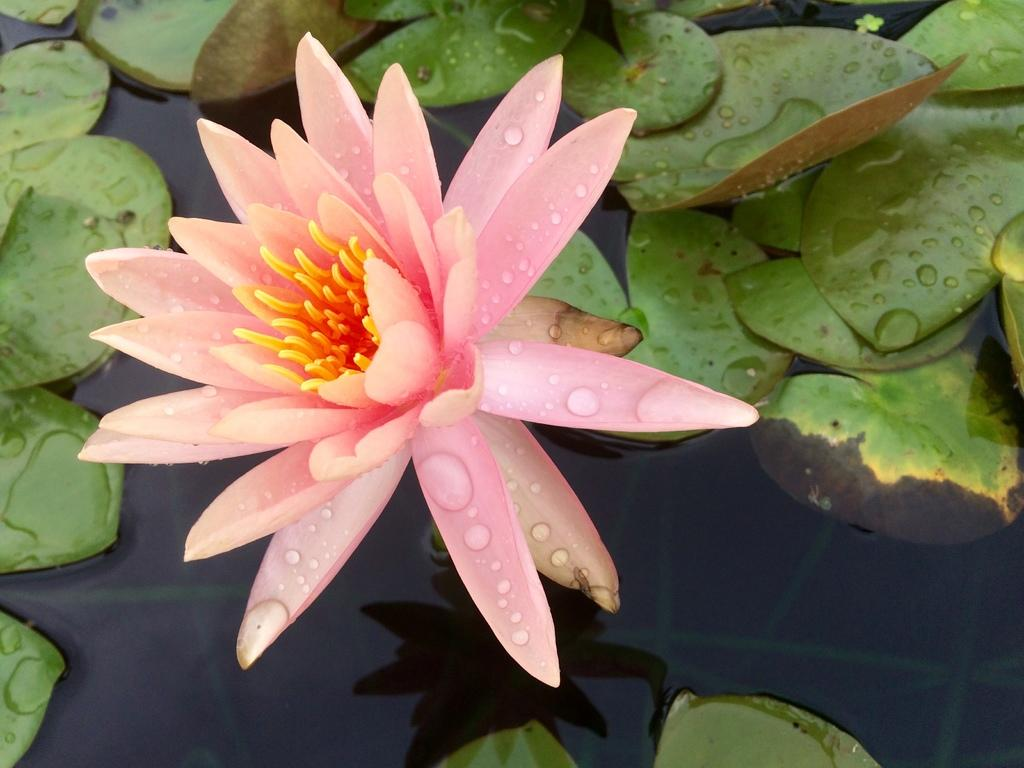What is the primary element visible in the image? There is water in the image. What type of plant material can be seen in the image? There are leaves in the image. What color is the flower in the image? There is a pink-colored flower in the image. What type of music can be heard playing in the background of the image? There is no music present in the image, as it is a still image and does not have any audible elements. 